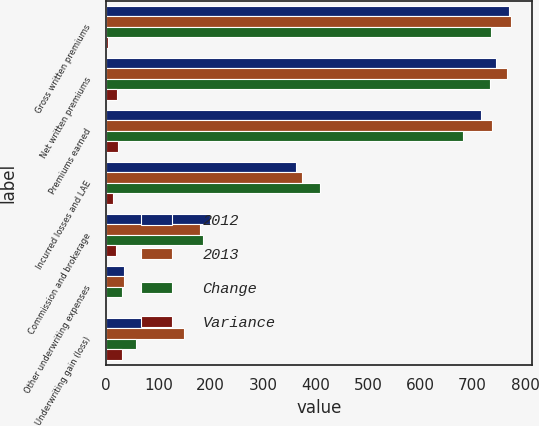Convert chart. <chart><loc_0><loc_0><loc_500><loc_500><stacked_bar_chart><ecel><fcel>Gross written premiums<fcel>Net written premiums<fcel>Premiums earned<fcel>Incurred losses and LAE<fcel>Commission and brokerage<fcel>Other underwriting expenses<fcel>Underwriting gain (loss)<nl><fcel>2012<fcel>770.2<fcel>744.7<fcel>715.7<fcel>361.8<fcel>198.8<fcel>34.9<fcel>120.2<nl><fcel>2013<fcel>774.3<fcel>765.7<fcel>738<fcel>374.4<fcel>179.1<fcel>34.7<fcel>149.8<nl><fcel>Change<fcel>734.4<fcel>733.8<fcel>680.9<fcel>408.2<fcel>184.4<fcel>30.6<fcel>57.8<nl><fcel>Variance<fcel>4<fcel>21<fcel>22.3<fcel>12.6<fcel>19.7<fcel>0.3<fcel>29.6<nl></chart> 